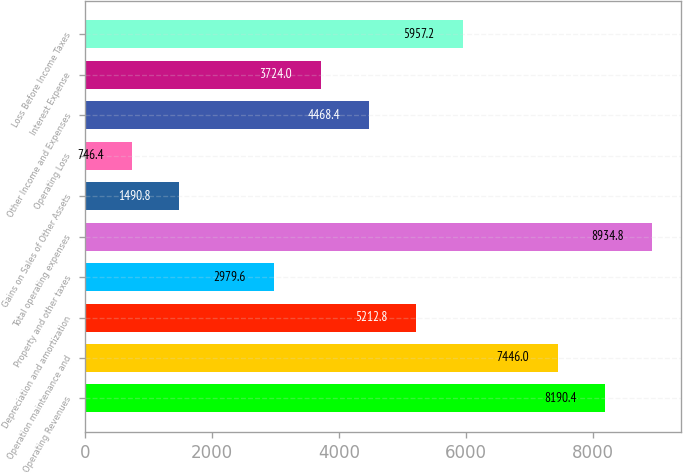Convert chart to OTSL. <chart><loc_0><loc_0><loc_500><loc_500><bar_chart><fcel>Operating Revenues<fcel>Operation maintenance and<fcel>Depreciation and amortization<fcel>Property and other taxes<fcel>Total operating expenses<fcel>Gains on Sales of Other Assets<fcel>Operating Loss<fcel>Other Income and Expenses<fcel>Interest Expense<fcel>Loss Before Income Taxes<nl><fcel>8190.4<fcel>7446<fcel>5212.8<fcel>2979.6<fcel>8934.8<fcel>1490.8<fcel>746.4<fcel>4468.4<fcel>3724<fcel>5957.2<nl></chart> 